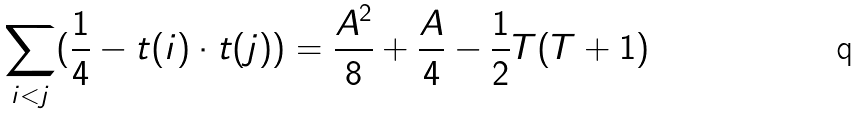Convert formula to latex. <formula><loc_0><loc_0><loc_500><loc_500>\sum _ { i < j } ( \frac { 1 } { 4 } - t ( i ) \cdot t ( j ) ) = \frac { A ^ { 2 } } { 8 } + \frac { A } { 4 } - \frac { 1 } { 2 } T ( T + 1 )</formula> 